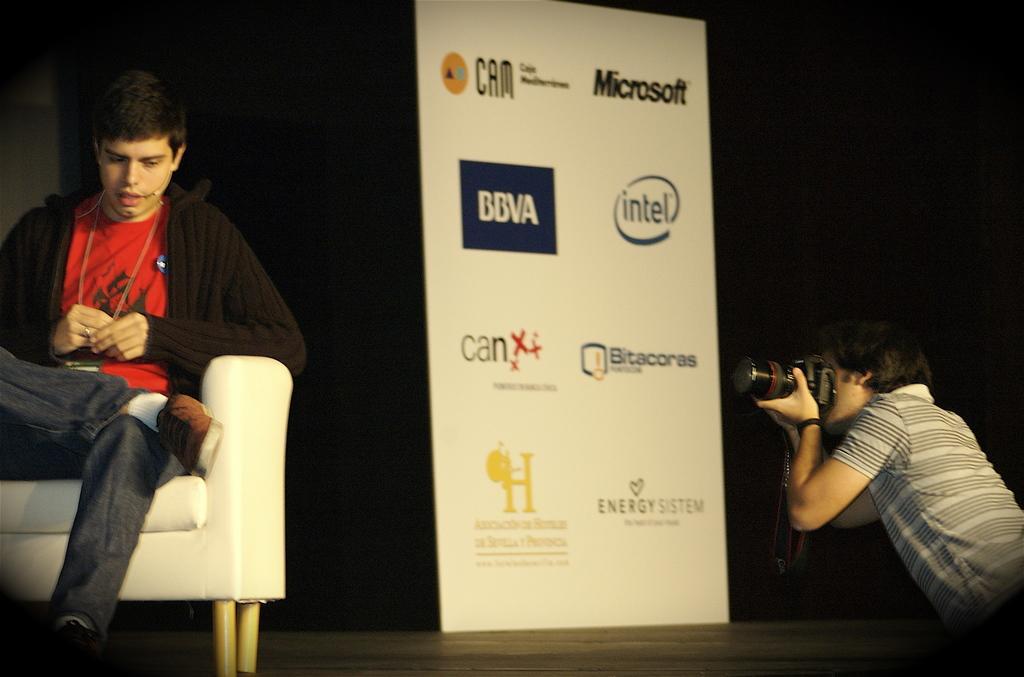Please provide a concise description of this image. On the left side of the image we can see a man sitting on the couch. On the right there is a man holding a camera. In the center we can see a banner. 